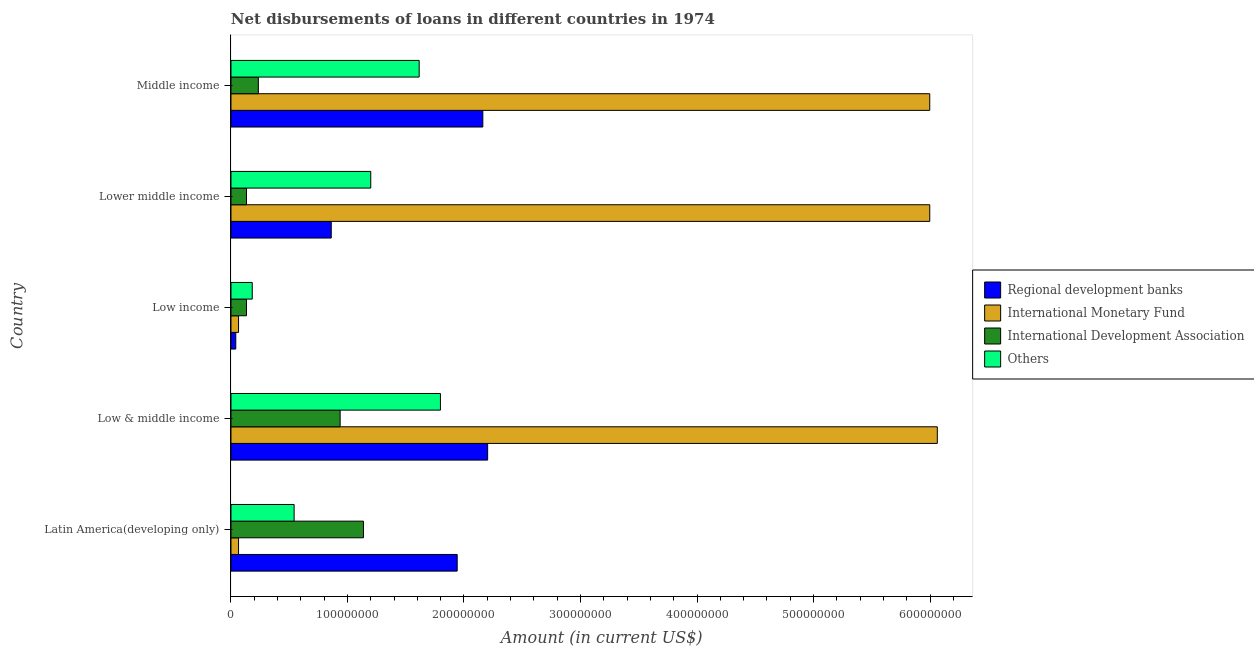Are the number of bars on each tick of the Y-axis equal?
Make the answer very short. Yes. What is the label of the 4th group of bars from the top?
Your answer should be very brief. Low & middle income. What is the amount of loan disimbursed by other organisations in Lower middle income?
Ensure brevity in your answer.  1.20e+08. Across all countries, what is the maximum amount of loan disimbursed by other organisations?
Offer a very short reply. 1.80e+08. Across all countries, what is the minimum amount of loan disimbursed by regional development banks?
Your answer should be very brief. 4.13e+06. In which country was the amount of loan disimbursed by international development association maximum?
Give a very brief answer. Latin America(developing only). In which country was the amount of loan disimbursed by regional development banks minimum?
Provide a succinct answer. Low income. What is the total amount of loan disimbursed by international monetary fund in the graph?
Your answer should be compact. 1.82e+09. What is the difference between the amount of loan disimbursed by international monetary fund in Low & middle income and that in Middle income?
Provide a succinct answer. 6.50e+06. What is the difference between the amount of loan disimbursed by international development association in Low & middle income and the amount of loan disimbursed by international monetary fund in Low income?
Offer a terse response. 8.72e+07. What is the average amount of loan disimbursed by international development association per country?
Ensure brevity in your answer.  5.15e+07. What is the difference between the amount of loan disimbursed by regional development banks and amount of loan disimbursed by other organisations in Middle income?
Your response must be concise. 5.46e+07. In how many countries, is the amount of loan disimbursed by regional development banks greater than 60000000 US$?
Provide a short and direct response. 4. What is the ratio of the amount of loan disimbursed by international development association in Latin America(developing only) to that in Low income?
Keep it short and to the point. 8.53. Is the amount of loan disimbursed by regional development banks in Latin America(developing only) less than that in Middle income?
Make the answer very short. Yes. Is the difference between the amount of loan disimbursed by international monetary fund in Low & middle income and Middle income greater than the difference between the amount of loan disimbursed by other organisations in Low & middle income and Middle income?
Offer a terse response. No. What is the difference between the highest and the second highest amount of loan disimbursed by regional development banks?
Your answer should be very brief. 4.13e+06. What is the difference between the highest and the lowest amount of loan disimbursed by international monetary fund?
Make the answer very short. 6.00e+08. Is the sum of the amount of loan disimbursed by international development association in Latin America(developing only) and Low income greater than the maximum amount of loan disimbursed by international monetary fund across all countries?
Your answer should be compact. No. Is it the case that in every country, the sum of the amount of loan disimbursed by international development association and amount of loan disimbursed by other organisations is greater than the sum of amount of loan disimbursed by regional development banks and amount of loan disimbursed by international monetary fund?
Offer a terse response. No. What does the 1st bar from the top in Low & middle income represents?
Offer a terse response. Others. What does the 4th bar from the bottom in Low & middle income represents?
Offer a terse response. Others. How many bars are there?
Make the answer very short. 20. How many countries are there in the graph?
Keep it short and to the point. 5. What is the difference between two consecutive major ticks on the X-axis?
Offer a very short reply. 1.00e+08. Does the graph contain grids?
Provide a succinct answer. No. How many legend labels are there?
Your response must be concise. 4. What is the title of the graph?
Make the answer very short. Net disbursements of loans in different countries in 1974. Does "Pre-primary schools" appear as one of the legend labels in the graph?
Offer a very short reply. No. What is the label or title of the X-axis?
Provide a succinct answer. Amount (in current US$). What is the Amount (in current US$) of Regional development banks in Latin America(developing only)?
Your answer should be very brief. 1.94e+08. What is the Amount (in current US$) of International Monetary Fund in Latin America(developing only)?
Your answer should be compact. 6.50e+06. What is the Amount (in current US$) in International Development Association in Latin America(developing only)?
Offer a terse response. 1.14e+08. What is the Amount (in current US$) in Others in Latin America(developing only)?
Ensure brevity in your answer.  5.42e+07. What is the Amount (in current US$) of Regional development banks in Low & middle income?
Ensure brevity in your answer.  2.20e+08. What is the Amount (in current US$) in International Monetary Fund in Low & middle income?
Your answer should be very brief. 6.06e+08. What is the Amount (in current US$) in International Development Association in Low & middle income?
Provide a succinct answer. 9.37e+07. What is the Amount (in current US$) of Others in Low & middle income?
Make the answer very short. 1.80e+08. What is the Amount (in current US$) of Regional development banks in Low income?
Keep it short and to the point. 4.13e+06. What is the Amount (in current US$) in International Monetary Fund in Low income?
Ensure brevity in your answer.  6.50e+06. What is the Amount (in current US$) of International Development Association in Low income?
Give a very brief answer. 1.33e+07. What is the Amount (in current US$) in Others in Low income?
Your answer should be very brief. 1.83e+07. What is the Amount (in current US$) in Regional development banks in Lower middle income?
Offer a very short reply. 8.61e+07. What is the Amount (in current US$) in International Monetary Fund in Lower middle income?
Give a very brief answer. 6.00e+08. What is the Amount (in current US$) of International Development Association in Lower middle income?
Ensure brevity in your answer.  1.33e+07. What is the Amount (in current US$) of Others in Lower middle income?
Ensure brevity in your answer.  1.20e+08. What is the Amount (in current US$) in Regional development banks in Middle income?
Ensure brevity in your answer.  2.16e+08. What is the Amount (in current US$) in International Monetary Fund in Middle income?
Make the answer very short. 6.00e+08. What is the Amount (in current US$) of International Development Association in Middle income?
Your answer should be compact. 2.35e+07. What is the Amount (in current US$) in Others in Middle income?
Give a very brief answer. 1.62e+08. Across all countries, what is the maximum Amount (in current US$) of Regional development banks?
Offer a very short reply. 2.20e+08. Across all countries, what is the maximum Amount (in current US$) of International Monetary Fund?
Make the answer very short. 6.06e+08. Across all countries, what is the maximum Amount (in current US$) in International Development Association?
Make the answer very short. 1.14e+08. Across all countries, what is the maximum Amount (in current US$) of Others?
Give a very brief answer. 1.80e+08. Across all countries, what is the minimum Amount (in current US$) in Regional development banks?
Provide a short and direct response. 4.13e+06. Across all countries, what is the minimum Amount (in current US$) of International Monetary Fund?
Provide a short and direct response. 6.50e+06. Across all countries, what is the minimum Amount (in current US$) in International Development Association?
Keep it short and to the point. 1.33e+07. Across all countries, what is the minimum Amount (in current US$) in Others?
Ensure brevity in your answer.  1.83e+07. What is the total Amount (in current US$) in Regional development banks in the graph?
Keep it short and to the point. 7.21e+08. What is the total Amount (in current US$) of International Monetary Fund in the graph?
Provide a short and direct response. 1.82e+09. What is the total Amount (in current US$) in International Development Association in the graph?
Your answer should be very brief. 2.58e+08. What is the total Amount (in current US$) in Others in the graph?
Offer a terse response. 5.34e+08. What is the difference between the Amount (in current US$) of Regional development banks in Latin America(developing only) and that in Low & middle income?
Give a very brief answer. -2.61e+07. What is the difference between the Amount (in current US$) in International Monetary Fund in Latin America(developing only) and that in Low & middle income?
Make the answer very short. -6.00e+08. What is the difference between the Amount (in current US$) in International Development Association in Latin America(developing only) and that in Low & middle income?
Provide a succinct answer. 2.00e+07. What is the difference between the Amount (in current US$) of Others in Latin America(developing only) and that in Low & middle income?
Your answer should be very brief. -1.26e+08. What is the difference between the Amount (in current US$) in Regional development banks in Latin America(developing only) and that in Low income?
Offer a very short reply. 1.90e+08. What is the difference between the Amount (in current US$) in International Monetary Fund in Latin America(developing only) and that in Low income?
Make the answer very short. 0. What is the difference between the Amount (in current US$) in International Development Association in Latin America(developing only) and that in Low income?
Offer a very short reply. 1.00e+08. What is the difference between the Amount (in current US$) in Others in Latin America(developing only) and that in Low income?
Make the answer very short. 3.59e+07. What is the difference between the Amount (in current US$) in Regional development banks in Latin America(developing only) and that in Lower middle income?
Make the answer very short. 1.08e+08. What is the difference between the Amount (in current US$) of International Monetary Fund in Latin America(developing only) and that in Lower middle income?
Your answer should be compact. -5.93e+08. What is the difference between the Amount (in current US$) in International Development Association in Latin America(developing only) and that in Lower middle income?
Your answer should be very brief. 1.00e+08. What is the difference between the Amount (in current US$) in Others in Latin America(developing only) and that in Lower middle income?
Provide a succinct answer. -6.58e+07. What is the difference between the Amount (in current US$) in Regional development banks in Latin America(developing only) and that in Middle income?
Ensure brevity in your answer.  -2.20e+07. What is the difference between the Amount (in current US$) in International Monetary Fund in Latin America(developing only) and that in Middle income?
Keep it short and to the point. -5.93e+08. What is the difference between the Amount (in current US$) of International Development Association in Latin America(developing only) and that in Middle income?
Give a very brief answer. 9.02e+07. What is the difference between the Amount (in current US$) of Others in Latin America(developing only) and that in Middle income?
Your response must be concise. -1.07e+08. What is the difference between the Amount (in current US$) in Regional development banks in Low & middle income and that in Low income?
Offer a terse response. 2.16e+08. What is the difference between the Amount (in current US$) in International Monetary Fund in Low & middle income and that in Low income?
Ensure brevity in your answer.  6.00e+08. What is the difference between the Amount (in current US$) in International Development Association in Low & middle income and that in Low income?
Offer a terse response. 8.04e+07. What is the difference between the Amount (in current US$) in Others in Low & middle income and that in Low income?
Offer a very short reply. 1.62e+08. What is the difference between the Amount (in current US$) in Regional development banks in Low & middle income and that in Lower middle income?
Your response must be concise. 1.34e+08. What is the difference between the Amount (in current US$) in International Monetary Fund in Low & middle income and that in Lower middle income?
Your response must be concise. 6.50e+06. What is the difference between the Amount (in current US$) of International Development Association in Low & middle income and that in Lower middle income?
Offer a terse response. 8.04e+07. What is the difference between the Amount (in current US$) of Others in Low & middle income and that in Lower middle income?
Ensure brevity in your answer.  5.98e+07. What is the difference between the Amount (in current US$) in Regional development banks in Low & middle income and that in Middle income?
Give a very brief answer. 4.13e+06. What is the difference between the Amount (in current US$) of International Monetary Fund in Low & middle income and that in Middle income?
Ensure brevity in your answer.  6.50e+06. What is the difference between the Amount (in current US$) in International Development Association in Low & middle income and that in Middle income?
Give a very brief answer. 7.02e+07. What is the difference between the Amount (in current US$) in Others in Low & middle income and that in Middle income?
Offer a terse response. 1.83e+07. What is the difference between the Amount (in current US$) in Regional development banks in Low income and that in Lower middle income?
Your response must be concise. -8.19e+07. What is the difference between the Amount (in current US$) in International Monetary Fund in Low income and that in Lower middle income?
Keep it short and to the point. -5.93e+08. What is the difference between the Amount (in current US$) in Others in Low income and that in Lower middle income?
Your answer should be compact. -1.02e+08. What is the difference between the Amount (in current US$) in Regional development banks in Low income and that in Middle income?
Provide a short and direct response. -2.12e+08. What is the difference between the Amount (in current US$) in International Monetary Fund in Low income and that in Middle income?
Keep it short and to the point. -5.93e+08. What is the difference between the Amount (in current US$) of International Development Association in Low income and that in Middle income?
Provide a succinct answer. -1.02e+07. What is the difference between the Amount (in current US$) of Others in Low income and that in Middle income?
Provide a short and direct response. -1.43e+08. What is the difference between the Amount (in current US$) of Regional development banks in Lower middle income and that in Middle income?
Your answer should be very brief. -1.30e+08. What is the difference between the Amount (in current US$) in International Development Association in Lower middle income and that in Middle income?
Your response must be concise. -1.02e+07. What is the difference between the Amount (in current US$) of Others in Lower middle income and that in Middle income?
Offer a very short reply. -4.16e+07. What is the difference between the Amount (in current US$) in Regional development banks in Latin America(developing only) and the Amount (in current US$) in International Monetary Fund in Low & middle income?
Keep it short and to the point. -4.12e+08. What is the difference between the Amount (in current US$) of Regional development banks in Latin America(developing only) and the Amount (in current US$) of International Development Association in Low & middle income?
Provide a short and direct response. 1.00e+08. What is the difference between the Amount (in current US$) of Regional development banks in Latin America(developing only) and the Amount (in current US$) of Others in Low & middle income?
Give a very brief answer. 1.44e+07. What is the difference between the Amount (in current US$) in International Monetary Fund in Latin America(developing only) and the Amount (in current US$) in International Development Association in Low & middle income?
Provide a succinct answer. -8.72e+07. What is the difference between the Amount (in current US$) of International Monetary Fund in Latin America(developing only) and the Amount (in current US$) of Others in Low & middle income?
Your answer should be very brief. -1.73e+08. What is the difference between the Amount (in current US$) in International Development Association in Latin America(developing only) and the Amount (in current US$) in Others in Low & middle income?
Keep it short and to the point. -6.61e+07. What is the difference between the Amount (in current US$) in Regional development banks in Latin America(developing only) and the Amount (in current US$) in International Monetary Fund in Low income?
Ensure brevity in your answer.  1.88e+08. What is the difference between the Amount (in current US$) of Regional development banks in Latin America(developing only) and the Amount (in current US$) of International Development Association in Low income?
Your answer should be compact. 1.81e+08. What is the difference between the Amount (in current US$) in Regional development banks in Latin America(developing only) and the Amount (in current US$) in Others in Low income?
Provide a succinct answer. 1.76e+08. What is the difference between the Amount (in current US$) of International Monetary Fund in Latin America(developing only) and the Amount (in current US$) of International Development Association in Low income?
Provide a short and direct response. -6.83e+06. What is the difference between the Amount (in current US$) in International Monetary Fund in Latin America(developing only) and the Amount (in current US$) in Others in Low income?
Keep it short and to the point. -1.18e+07. What is the difference between the Amount (in current US$) of International Development Association in Latin America(developing only) and the Amount (in current US$) of Others in Low income?
Keep it short and to the point. 9.54e+07. What is the difference between the Amount (in current US$) in Regional development banks in Latin America(developing only) and the Amount (in current US$) in International Monetary Fund in Lower middle income?
Your response must be concise. -4.06e+08. What is the difference between the Amount (in current US$) of Regional development banks in Latin America(developing only) and the Amount (in current US$) of International Development Association in Lower middle income?
Offer a terse response. 1.81e+08. What is the difference between the Amount (in current US$) in Regional development banks in Latin America(developing only) and the Amount (in current US$) in Others in Lower middle income?
Your answer should be very brief. 7.42e+07. What is the difference between the Amount (in current US$) in International Monetary Fund in Latin America(developing only) and the Amount (in current US$) in International Development Association in Lower middle income?
Provide a succinct answer. -6.83e+06. What is the difference between the Amount (in current US$) of International Monetary Fund in Latin America(developing only) and the Amount (in current US$) of Others in Lower middle income?
Ensure brevity in your answer.  -1.13e+08. What is the difference between the Amount (in current US$) in International Development Association in Latin America(developing only) and the Amount (in current US$) in Others in Lower middle income?
Keep it short and to the point. -6.26e+06. What is the difference between the Amount (in current US$) in Regional development banks in Latin America(developing only) and the Amount (in current US$) in International Monetary Fund in Middle income?
Make the answer very short. -4.06e+08. What is the difference between the Amount (in current US$) in Regional development banks in Latin America(developing only) and the Amount (in current US$) in International Development Association in Middle income?
Provide a short and direct response. 1.71e+08. What is the difference between the Amount (in current US$) in Regional development banks in Latin America(developing only) and the Amount (in current US$) in Others in Middle income?
Provide a short and direct response. 3.26e+07. What is the difference between the Amount (in current US$) in International Monetary Fund in Latin America(developing only) and the Amount (in current US$) in International Development Association in Middle income?
Make the answer very short. -1.70e+07. What is the difference between the Amount (in current US$) in International Monetary Fund in Latin America(developing only) and the Amount (in current US$) in Others in Middle income?
Your answer should be very brief. -1.55e+08. What is the difference between the Amount (in current US$) of International Development Association in Latin America(developing only) and the Amount (in current US$) of Others in Middle income?
Offer a very short reply. -4.78e+07. What is the difference between the Amount (in current US$) in Regional development banks in Low & middle income and the Amount (in current US$) in International Monetary Fund in Low income?
Make the answer very short. 2.14e+08. What is the difference between the Amount (in current US$) of Regional development banks in Low & middle income and the Amount (in current US$) of International Development Association in Low income?
Your answer should be compact. 2.07e+08. What is the difference between the Amount (in current US$) in Regional development banks in Low & middle income and the Amount (in current US$) in Others in Low income?
Provide a short and direct response. 2.02e+08. What is the difference between the Amount (in current US$) of International Monetary Fund in Low & middle income and the Amount (in current US$) of International Development Association in Low income?
Your response must be concise. 5.93e+08. What is the difference between the Amount (in current US$) of International Monetary Fund in Low & middle income and the Amount (in current US$) of Others in Low income?
Your response must be concise. 5.88e+08. What is the difference between the Amount (in current US$) in International Development Association in Low & middle income and the Amount (in current US$) in Others in Low income?
Your response must be concise. 7.54e+07. What is the difference between the Amount (in current US$) of Regional development banks in Low & middle income and the Amount (in current US$) of International Monetary Fund in Lower middle income?
Give a very brief answer. -3.79e+08. What is the difference between the Amount (in current US$) of Regional development banks in Low & middle income and the Amount (in current US$) of International Development Association in Lower middle income?
Ensure brevity in your answer.  2.07e+08. What is the difference between the Amount (in current US$) in Regional development banks in Low & middle income and the Amount (in current US$) in Others in Lower middle income?
Provide a succinct answer. 1.00e+08. What is the difference between the Amount (in current US$) in International Monetary Fund in Low & middle income and the Amount (in current US$) in International Development Association in Lower middle income?
Offer a very short reply. 5.93e+08. What is the difference between the Amount (in current US$) in International Monetary Fund in Low & middle income and the Amount (in current US$) in Others in Lower middle income?
Provide a succinct answer. 4.86e+08. What is the difference between the Amount (in current US$) of International Development Association in Low & middle income and the Amount (in current US$) of Others in Lower middle income?
Keep it short and to the point. -2.63e+07. What is the difference between the Amount (in current US$) in Regional development banks in Low & middle income and the Amount (in current US$) in International Monetary Fund in Middle income?
Your response must be concise. -3.79e+08. What is the difference between the Amount (in current US$) in Regional development banks in Low & middle income and the Amount (in current US$) in International Development Association in Middle income?
Your response must be concise. 1.97e+08. What is the difference between the Amount (in current US$) of Regional development banks in Low & middle income and the Amount (in current US$) of Others in Middle income?
Ensure brevity in your answer.  5.88e+07. What is the difference between the Amount (in current US$) in International Monetary Fund in Low & middle income and the Amount (in current US$) in International Development Association in Middle income?
Your response must be concise. 5.83e+08. What is the difference between the Amount (in current US$) of International Monetary Fund in Low & middle income and the Amount (in current US$) of Others in Middle income?
Make the answer very short. 4.45e+08. What is the difference between the Amount (in current US$) in International Development Association in Low & middle income and the Amount (in current US$) in Others in Middle income?
Provide a succinct answer. -6.78e+07. What is the difference between the Amount (in current US$) in Regional development banks in Low income and the Amount (in current US$) in International Monetary Fund in Lower middle income?
Keep it short and to the point. -5.96e+08. What is the difference between the Amount (in current US$) in Regional development banks in Low income and the Amount (in current US$) in International Development Association in Lower middle income?
Ensure brevity in your answer.  -9.20e+06. What is the difference between the Amount (in current US$) in Regional development banks in Low income and the Amount (in current US$) in Others in Lower middle income?
Ensure brevity in your answer.  -1.16e+08. What is the difference between the Amount (in current US$) in International Monetary Fund in Low income and the Amount (in current US$) in International Development Association in Lower middle income?
Give a very brief answer. -6.83e+06. What is the difference between the Amount (in current US$) in International Monetary Fund in Low income and the Amount (in current US$) in Others in Lower middle income?
Offer a very short reply. -1.13e+08. What is the difference between the Amount (in current US$) in International Development Association in Low income and the Amount (in current US$) in Others in Lower middle income?
Offer a terse response. -1.07e+08. What is the difference between the Amount (in current US$) in Regional development banks in Low income and the Amount (in current US$) in International Monetary Fund in Middle income?
Your response must be concise. -5.96e+08. What is the difference between the Amount (in current US$) of Regional development banks in Low income and the Amount (in current US$) of International Development Association in Middle income?
Give a very brief answer. -1.94e+07. What is the difference between the Amount (in current US$) in Regional development banks in Low income and the Amount (in current US$) in Others in Middle income?
Your response must be concise. -1.57e+08. What is the difference between the Amount (in current US$) in International Monetary Fund in Low income and the Amount (in current US$) in International Development Association in Middle income?
Give a very brief answer. -1.70e+07. What is the difference between the Amount (in current US$) in International Monetary Fund in Low income and the Amount (in current US$) in Others in Middle income?
Your answer should be compact. -1.55e+08. What is the difference between the Amount (in current US$) in International Development Association in Low income and the Amount (in current US$) in Others in Middle income?
Keep it short and to the point. -1.48e+08. What is the difference between the Amount (in current US$) in Regional development banks in Lower middle income and the Amount (in current US$) in International Monetary Fund in Middle income?
Provide a short and direct response. -5.14e+08. What is the difference between the Amount (in current US$) of Regional development banks in Lower middle income and the Amount (in current US$) of International Development Association in Middle income?
Provide a short and direct response. 6.26e+07. What is the difference between the Amount (in current US$) in Regional development banks in Lower middle income and the Amount (in current US$) in Others in Middle income?
Provide a short and direct response. -7.55e+07. What is the difference between the Amount (in current US$) in International Monetary Fund in Lower middle income and the Amount (in current US$) in International Development Association in Middle income?
Your answer should be compact. 5.76e+08. What is the difference between the Amount (in current US$) in International Monetary Fund in Lower middle income and the Amount (in current US$) in Others in Middle income?
Keep it short and to the point. 4.38e+08. What is the difference between the Amount (in current US$) in International Development Association in Lower middle income and the Amount (in current US$) in Others in Middle income?
Give a very brief answer. -1.48e+08. What is the average Amount (in current US$) in Regional development banks per country?
Give a very brief answer. 1.44e+08. What is the average Amount (in current US$) of International Monetary Fund per country?
Your answer should be compact. 3.64e+08. What is the average Amount (in current US$) in International Development Association per country?
Offer a very short reply. 5.15e+07. What is the average Amount (in current US$) of Others per country?
Offer a terse response. 1.07e+08. What is the difference between the Amount (in current US$) of Regional development banks and Amount (in current US$) of International Monetary Fund in Latin America(developing only)?
Give a very brief answer. 1.88e+08. What is the difference between the Amount (in current US$) in Regional development banks and Amount (in current US$) in International Development Association in Latin America(developing only)?
Provide a succinct answer. 8.05e+07. What is the difference between the Amount (in current US$) in Regional development banks and Amount (in current US$) in Others in Latin America(developing only)?
Your response must be concise. 1.40e+08. What is the difference between the Amount (in current US$) of International Monetary Fund and Amount (in current US$) of International Development Association in Latin America(developing only)?
Keep it short and to the point. -1.07e+08. What is the difference between the Amount (in current US$) in International Monetary Fund and Amount (in current US$) in Others in Latin America(developing only)?
Provide a succinct answer. -4.77e+07. What is the difference between the Amount (in current US$) of International Development Association and Amount (in current US$) of Others in Latin America(developing only)?
Your answer should be compact. 5.95e+07. What is the difference between the Amount (in current US$) of Regional development banks and Amount (in current US$) of International Monetary Fund in Low & middle income?
Your answer should be compact. -3.86e+08. What is the difference between the Amount (in current US$) of Regional development banks and Amount (in current US$) of International Development Association in Low & middle income?
Give a very brief answer. 1.27e+08. What is the difference between the Amount (in current US$) in Regional development banks and Amount (in current US$) in Others in Low & middle income?
Your response must be concise. 4.05e+07. What is the difference between the Amount (in current US$) in International Monetary Fund and Amount (in current US$) in International Development Association in Low & middle income?
Offer a terse response. 5.13e+08. What is the difference between the Amount (in current US$) of International Monetary Fund and Amount (in current US$) of Others in Low & middle income?
Your response must be concise. 4.26e+08. What is the difference between the Amount (in current US$) in International Development Association and Amount (in current US$) in Others in Low & middle income?
Keep it short and to the point. -8.61e+07. What is the difference between the Amount (in current US$) in Regional development banks and Amount (in current US$) in International Monetary Fund in Low income?
Keep it short and to the point. -2.37e+06. What is the difference between the Amount (in current US$) in Regional development banks and Amount (in current US$) in International Development Association in Low income?
Ensure brevity in your answer.  -9.20e+06. What is the difference between the Amount (in current US$) in Regional development banks and Amount (in current US$) in Others in Low income?
Provide a succinct answer. -1.41e+07. What is the difference between the Amount (in current US$) of International Monetary Fund and Amount (in current US$) of International Development Association in Low income?
Your answer should be very brief. -6.83e+06. What is the difference between the Amount (in current US$) of International Monetary Fund and Amount (in current US$) of Others in Low income?
Your answer should be compact. -1.18e+07. What is the difference between the Amount (in current US$) of International Development Association and Amount (in current US$) of Others in Low income?
Offer a very short reply. -4.93e+06. What is the difference between the Amount (in current US$) of Regional development banks and Amount (in current US$) of International Monetary Fund in Lower middle income?
Give a very brief answer. -5.14e+08. What is the difference between the Amount (in current US$) in Regional development banks and Amount (in current US$) in International Development Association in Lower middle income?
Give a very brief answer. 7.27e+07. What is the difference between the Amount (in current US$) in Regional development banks and Amount (in current US$) in Others in Lower middle income?
Keep it short and to the point. -3.39e+07. What is the difference between the Amount (in current US$) of International Monetary Fund and Amount (in current US$) of International Development Association in Lower middle income?
Your response must be concise. 5.86e+08. What is the difference between the Amount (in current US$) in International Monetary Fund and Amount (in current US$) in Others in Lower middle income?
Offer a very short reply. 4.80e+08. What is the difference between the Amount (in current US$) in International Development Association and Amount (in current US$) in Others in Lower middle income?
Your response must be concise. -1.07e+08. What is the difference between the Amount (in current US$) of Regional development banks and Amount (in current US$) of International Monetary Fund in Middle income?
Offer a terse response. -3.84e+08. What is the difference between the Amount (in current US$) in Regional development banks and Amount (in current US$) in International Development Association in Middle income?
Make the answer very short. 1.93e+08. What is the difference between the Amount (in current US$) of Regional development banks and Amount (in current US$) of Others in Middle income?
Make the answer very short. 5.46e+07. What is the difference between the Amount (in current US$) in International Monetary Fund and Amount (in current US$) in International Development Association in Middle income?
Keep it short and to the point. 5.76e+08. What is the difference between the Amount (in current US$) of International Monetary Fund and Amount (in current US$) of Others in Middle income?
Keep it short and to the point. 4.38e+08. What is the difference between the Amount (in current US$) of International Development Association and Amount (in current US$) of Others in Middle income?
Offer a very short reply. -1.38e+08. What is the ratio of the Amount (in current US$) of Regional development banks in Latin America(developing only) to that in Low & middle income?
Offer a terse response. 0.88. What is the ratio of the Amount (in current US$) of International Monetary Fund in Latin America(developing only) to that in Low & middle income?
Your answer should be very brief. 0.01. What is the ratio of the Amount (in current US$) in International Development Association in Latin America(developing only) to that in Low & middle income?
Your response must be concise. 1.21. What is the ratio of the Amount (in current US$) of Others in Latin America(developing only) to that in Low & middle income?
Keep it short and to the point. 0.3. What is the ratio of the Amount (in current US$) in Regional development banks in Latin America(developing only) to that in Low income?
Provide a short and direct response. 47.06. What is the ratio of the Amount (in current US$) of International Monetary Fund in Latin America(developing only) to that in Low income?
Ensure brevity in your answer.  1. What is the ratio of the Amount (in current US$) of International Development Association in Latin America(developing only) to that in Low income?
Give a very brief answer. 8.53. What is the ratio of the Amount (in current US$) in Others in Latin America(developing only) to that in Low income?
Your answer should be very brief. 2.97. What is the ratio of the Amount (in current US$) of Regional development banks in Latin America(developing only) to that in Lower middle income?
Make the answer very short. 2.26. What is the ratio of the Amount (in current US$) of International Monetary Fund in Latin America(developing only) to that in Lower middle income?
Offer a terse response. 0.01. What is the ratio of the Amount (in current US$) in International Development Association in Latin America(developing only) to that in Lower middle income?
Your answer should be compact. 8.53. What is the ratio of the Amount (in current US$) of Others in Latin America(developing only) to that in Lower middle income?
Your response must be concise. 0.45. What is the ratio of the Amount (in current US$) in Regional development banks in Latin America(developing only) to that in Middle income?
Provide a succinct answer. 0.9. What is the ratio of the Amount (in current US$) in International Monetary Fund in Latin America(developing only) to that in Middle income?
Offer a terse response. 0.01. What is the ratio of the Amount (in current US$) of International Development Association in Latin America(developing only) to that in Middle income?
Make the answer very short. 4.84. What is the ratio of the Amount (in current US$) in Others in Latin America(developing only) to that in Middle income?
Ensure brevity in your answer.  0.34. What is the ratio of the Amount (in current US$) of Regional development banks in Low & middle income to that in Low income?
Keep it short and to the point. 53.39. What is the ratio of the Amount (in current US$) of International Monetary Fund in Low & middle income to that in Low income?
Make the answer very short. 93.27. What is the ratio of the Amount (in current US$) in International Development Association in Low & middle income to that in Low income?
Your answer should be compact. 7.03. What is the ratio of the Amount (in current US$) in Others in Low & middle income to that in Low income?
Ensure brevity in your answer.  9.85. What is the ratio of the Amount (in current US$) of Regional development banks in Low & middle income to that in Lower middle income?
Offer a terse response. 2.56. What is the ratio of the Amount (in current US$) in International Monetary Fund in Low & middle income to that in Lower middle income?
Your answer should be compact. 1.01. What is the ratio of the Amount (in current US$) of International Development Association in Low & middle income to that in Lower middle income?
Ensure brevity in your answer.  7.03. What is the ratio of the Amount (in current US$) of Others in Low & middle income to that in Lower middle income?
Offer a terse response. 1.5. What is the ratio of the Amount (in current US$) in Regional development banks in Low & middle income to that in Middle income?
Offer a very short reply. 1.02. What is the ratio of the Amount (in current US$) in International Monetary Fund in Low & middle income to that in Middle income?
Give a very brief answer. 1.01. What is the ratio of the Amount (in current US$) of International Development Association in Low & middle income to that in Middle income?
Make the answer very short. 3.99. What is the ratio of the Amount (in current US$) in Others in Low & middle income to that in Middle income?
Offer a very short reply. 1.11. What is the ratio of the Amount (in current US$) in Regional development banks in Low income to that in Lower middle income?
Your answer should be compact. 0.05. What is the ratio of the Amount (in current US$) in International Monetary Fund in Low income to that in Lower middle income?
Give a very brief answer. 0.01. What is the ratio of the Amount (in current US$) of Others in Low income to that in Lower middle income?
Your response must be concise. 0.15. What is the ratio of the Amount (in current US$) of Regional development banks in Low income to that in Middle income?
Provide a short and direct response. 0.02. What is the ratio of the Amount (in current US$) of International Monetary Fund in Low income to that in Middle income?
Your answer should be very brief. 0.01. What is the ratio of the Amount (in current US$) in International Development Association in Low income to that in Middle income?
Your response must be concise. 0.57. What is the ratio of the Amount (in current US$) of Others in Low income to that in Middle income?
Offer a terse response. 0.11. What is the ratio of the Amount (in current US$) of Regional development banks in Lower middle income to that in Middle income?
Your answer should be very brief. 0.4. What is the ratio of the Amount (in current US$) in International Development Association in Lower middle income to that in Middle income?
Offer a very short reply. 0.57. What is the ratio of the Amount (in current US$) in Others in Lower middle income to that in Middle income?
Offer a very short reply. 0.74. What is the difference between the highest and the second highest Amount (in current US$) in Regional development banks?
Ensure brevity in your answer.  4.13e+06. What is the difference between the highest and the second highest Amount (in current US$) of International Monetary Fund?
Provide a short and direct response. 6.50e+06. What is the difference between the highest and the second highest Amount (in current US$) of International Development Association?
Make the answer very short. 2.00e+07. What is the difference between the highest and the second highest Amount (in current US$) of Others?
Offer a terse response. 1.83e+07. What is the difference between the highest and the lowest Amount (in current US$) of Regional development banks?
Your response must be concise. 2.16e+08. What is the difference between the highest and the lowest Amount (in current US$) of International Monetary Fund?
Keep it short and to the point. 6.00e+08. What is the difference between the highest and the lowest Amount (in current US$) in International Development Association?
Offer a terse response. 1.00e+08. What is the difference between the highest and the lowest Amount (in current US$) of Others?
Provide a short and direct response. 1.62e+08. 